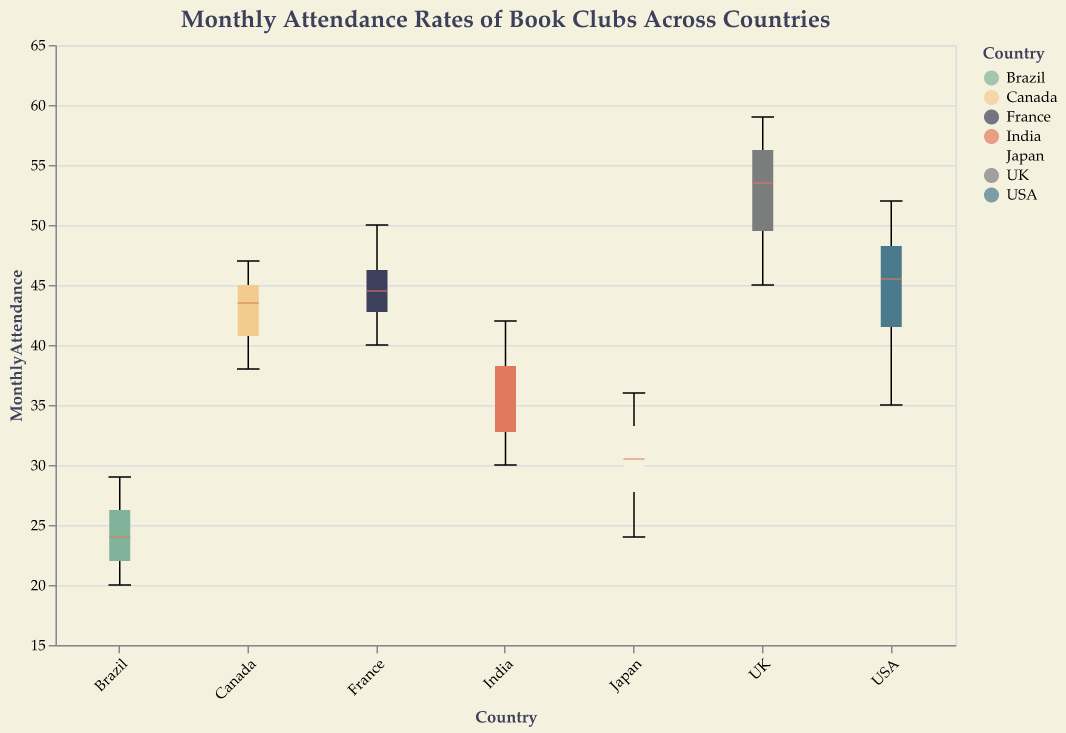What is the title of the figure? The title of the figure is displayed at the top and indicates the main topic being presented. In this case, it is "Monthly Attendance Rates of Book Clubs Across Countries."
Answer: Monthly Attendance Rates of Book Clubs Across Countries Which country has the highest median monthly attendance rate? The median monthly attendance rate for each country is marked by a distinct line inside each boxplot. The country with the highest median, indicated by the marked line being the highest on the y-axis, is the UK.
Answer: UK What is the range of monthly attendance rates for book clubs in Brazil? The range is indicated by the min and max lines extending from the box. For Brazil, the lowest attendance rate is 20, and the highest is 29.
Answer: 20 to 29 How does the median monthly attendance in Japan compare to that in France? The median is marked by a line within each box. For Japan, the median is close to 30, while for France, it is around 45, indicating that France's median attendance is higher than Japan’s.
Answer: France's median is higher Which country has the smallest interquartile range (IQR) for monthly attendance rates? The IQR is represented by the height of the box in the boxplot. A smaller box indicates a smaller IQR. India has the smallest interquartile range, shown by the narrowest box.
Answer: India How do the maximum monthly attendance rates compare between USA and Canada? The maximum values are indicated by the top whisker of each boxplot. The USA's maximum attendance (around 52) is slightly higher than Canada's (around 47).
Answer: USA is higher Which country has the most consistent monthly attendance rates? Consistency in attendance rates is reflected by a smaller IQR and shorter whiskers. Brazil, with a narrow box and short whiskers, has the most consistent attendance rates.
Answer: Brazil What can you infer from the notches of the boxplots about the median comparisons? The notches in the boxplots indicate the confidence interval around the median. If the notches of two boxes do not overlap, it suggests that their medians are significantly different. The notches of the UK and other countries do not overlap significantly, indicating a noticeable difference in medians.
Answer: The UK's median is significantly different from others What is the median monthly attendance rate for book clubs in France? The median rate is represented by the line within France's boxplot. For France, the median is around 45.
Answer: 45 